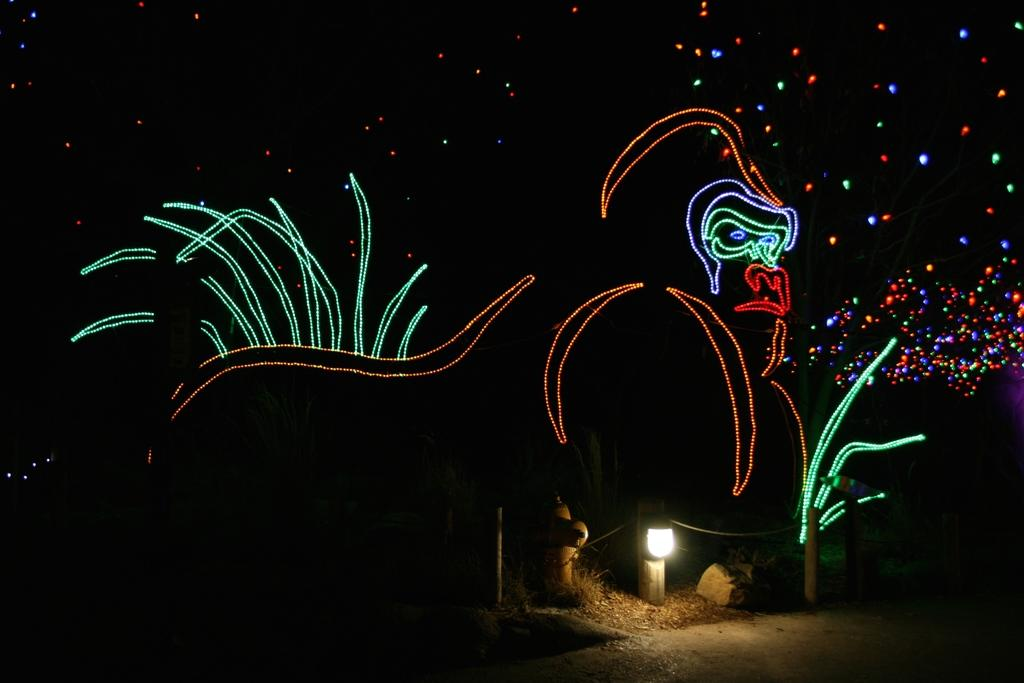What is the main subject of the image? The main subject of the image is a picture of a gorilla. How is the picture of the gorilla decorated? The picture of the gorilla is decorated with lights. What other objects can be seen in the image? There appears to be a fire hydrant and a rock in the image. Is there any lighting equipment visible in the image? Yes, there is a light attached to a small pole in the image. What type of lace is draped over the gorilla in the image? There is no lace present in the image; the gorilla picture is decorated with lights. Can you tell me how many vans are parked near the fire hydrant in the image? There are no vans present in the image; only a fire hydrant, a rock, and a light attached to a small pole are visible. 